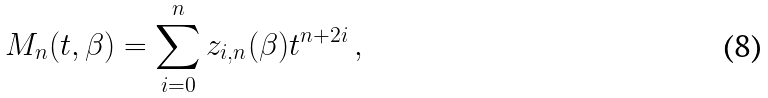Convert formula to latex. <formula><loc_0><loc_0><loc_500><loc_500>M _ { n } ( t , \beta ) = \sum _ { i = 0 } ^ { n } z _ { i , n } ( \beta ) t ^ { n + 2 i } \, ,</formula> 